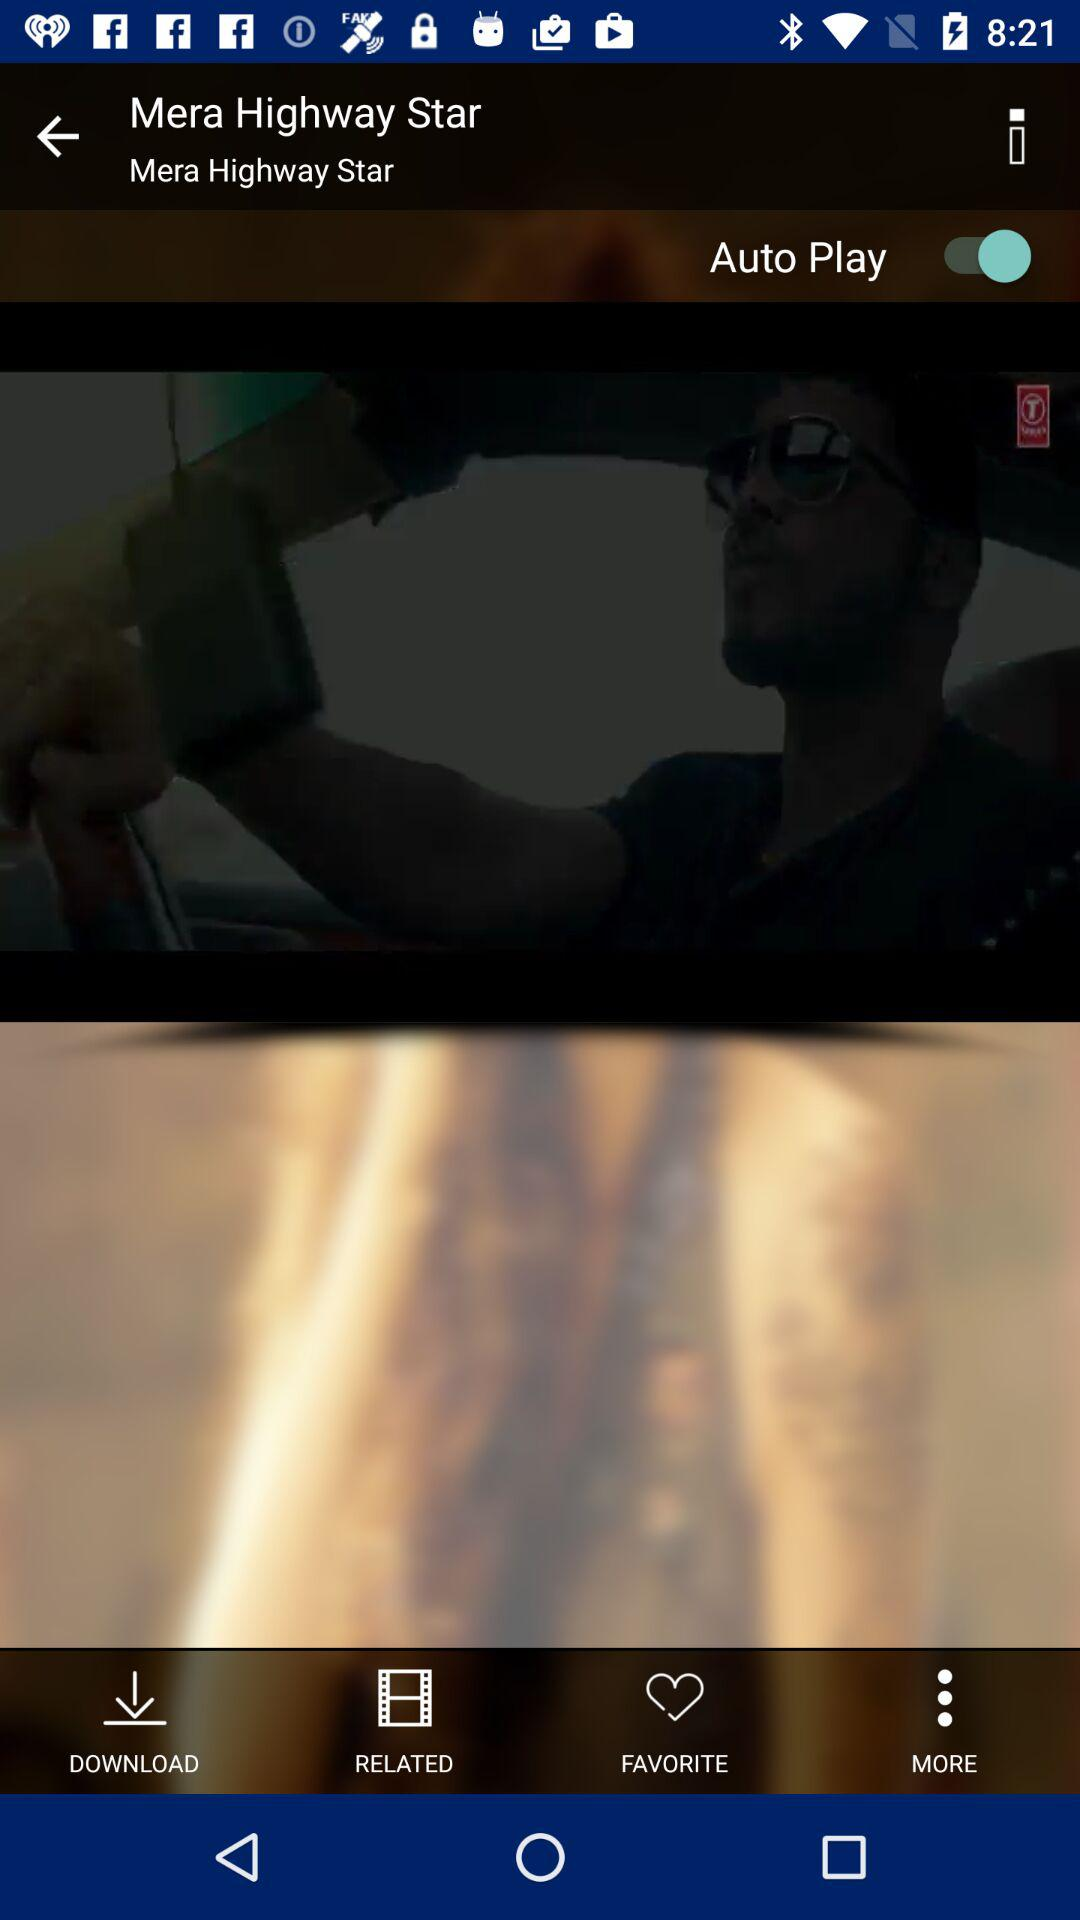What is the status of "Auto Play"? The status is "on". 